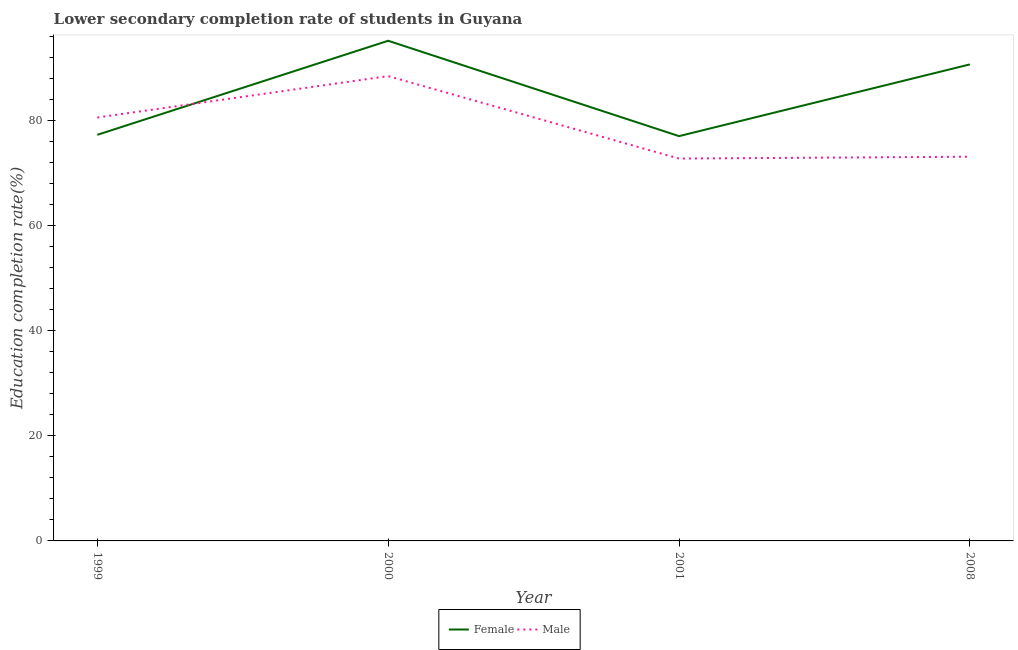How many different coloured lines are there?
Offer a very short reply. 2. Is the number of lines equal to the number of legend labels?
Offer a very short reply. Yes. What is the education completion rate of female students in 2001?
Provide a succinct answer. 77.08. Across all years, what is the maximum education completion rate of female students?
Your answer should be very brief. 95.24. Across all years, what is the minimum education completion rate of male students?
Your answer should be very brief. 72.8. In which year was the education completion rate of male students minimum?
Offer a terse response. 2001. What is the total education completion rate of male students in the graph?
Offer a terse response. 315.09. What is the difference between the education completion rate of female students in 2000 and that in 2001?
Give a very brief answer. 18.16. What is the difference between the education completion rate of female students in 2008 and the education completion rate of male students in 2000?
Provide a short and direct response. 2.23. What is the average education completion rate of male students per year?
Keep it short and to the point. 78.77. In the year 2001, what is the difference between the education completion rate of male students and education completion rate of female students?
Make the answer very short. -4.28. In how many years, is the education completion rate of female students greater than 4 %?
Your answer should be very brief. 4. What is the ratio of the education completion rate of female students in 1999 to that in 2008?
Provide a short and direct response. 0.85. Is the difference between the education completion rate of female students in 1999 and 2000 greater than the difference between the education completion rate of male students in 1999 and 2000?
Offer a terse response. No. What is the difference between the highest and the second highest education completion rate of female students?
Offer a terse response. 4.5. What is the difference between the highest and the lowest education completion rate of male students?
Keep it short and to the point. 15.7. In how many years, is the education completion rate of male students greater than the average education completion rate of male students taken over all years?
Your response must be concise. 2. Is the sum of the education completion rate of female students in 2000 and 2001 greater than the maximum education completion rate of male students across all years?
Your answer should be very brief. Yes. Is the education completion rate of female students strictly greater than the education completion rate of male students over the years?
Your answer should be compact. No. How many lines are there?
Offer a terse response. 2. Are the values on the major ticks of Y-axis written in scientific E-notation?
Make the answer very short. No. Does the graph contain any zero values?
Make the answer very short. No. How many legend labels are there?
Give a very brief answer. 2. What is the title of the graph?
Give a very brief answer. Lower secondary completion rate of students in Guyana. Does "Working only" appear as one of the legend labels in the graph?
Offer a terse response. No. What is the label or title of the X-axis?
Ensure brevity in your answer.  Year. What is the label or title of the Y-axis?
Your response must be concise. Education completion rate(%). What is the Education completion rate(%) of Female in 1999?
Provide a short and direct response. 77.33. What is the Education completion rate(%) of Male in 1999?
Give a very brief answer. 80.62. What is the Education completion rate(%) in Female in 2000?
Your answer should be very brief. 95.24. What is the Education completion rate(%) in Male in 2000?
Keep it short and to the point. 88.5. What is the Education completion rate(%) in Female in 2001?
Provide a short and direct response. 77.08. What is the Education completion rate(%) in Male in 2001?
Your answer should be compact. 72.8. What is the Education completion rate(%) in Female in 2008?
Provide a succinct answer. 90.73. What is the Education completion rate(%) of Male in 2008?
Your answer should be compact. 73.16. Across all years, what is the maximum Education completion rate(%) of Female?
Ensure brevity in your answer.  95.24. Across all years, what is the maximum Education completion rate(%) of Male?
Offer a very short reply. 88.5. Across all years, what is the minimum Education completion rate(%) of Female?
Your answer should be compact. 77.08. Across all years, what is the minimum Education completion rate(%) in Male?
Offer a terse response. 72.8. What is the total Education completion rate(%) of Female in the graph?
Provide a succinct answer. 340.38. What is the total Education completion rate(%) in Male in the graph?
Your answer should be very brief. 315.09. What is the difference between the Education completion rate(%) in Female in 1999 and that in 2000?
Keep it short and to the point. -17.91. What is the difference between the Education completion rate(%) of Male in 1999 and that in 2000?
Your response must be concise. -7.88. What is the difference between the Education completion rate(%) in Female in 1999 and that in 2001?
Your answer should be compact. 0.25. What is the difference between the Education completion rate(%) of Male in 1999 and that in 2001?
Your answer should be compact. 7.82. What is the difference between the Education completion rate(%) in Female in 1999 and that in 2008?
Your answer should be compact. -13.41. What is the difference between the Education completion rate(%) of Male in 1999 and that in 2008?
Provide a short and direct response. 7.47. What is the difference between the Education completion rate(%) of Female in 2000 and that in 2001?
Keep it short and to the point. 18.16. What is the difference between the Education completion rate(%) of Male in 2000 and that in 2001?
Ensure brevity in your answer.  15.7. What is the difference between the Education completion rate(%) of Female in 2000 and that in 2008?
Provide a succinct answer. 4.5. What is the difference between the Education completion rate(%) of Male in 2000 and that in 2008?
Offer a very short reply. 15.34. What is the difference between the Education completion rate(%) of Female in 2001 and that in 2008?
Your answer should be compact. -13.66. What is the difference between the Education completion rate(%) in Male in 2001 and that in 2008?
Ensure brevity in your answer.  -0.36. What is the difference between the Education completion rate(%) in Female in 1999 and the Education completion rate(%) in Male in 2000?
Ensure brevity in your answer.  -11.18. What is the difference between the Education completion rate(%) of Female in 1999 and the Education completion rate(%) of Male in 2001?
Your answer should be compact. 4.52. What is the difference between the Education completion rate(%) in Female in 1999 and the Education completion rate(%) in Male in 2008?
Give a very brief answer. 4.17. What is the difference between the Education completion rate(%) of Female in 2000 and the Education completion rate(%) of Male in 2001?
Make the answer very short. 22.43. What is the difference between the Education completion rate(%) in Female in 2000 and the Education completion rate(%) in Male in 2008?
Make the answer very short. 22.08. What is the difference between the Education completion rate(%) in Female in 2001 and the Education completion rate(%) in Male in 2008?
Give a very brief answer. 3.92. What is the average Education completion rate(%) in Female per year?
Ensure brevity in your answer.  85.09. What is the average Education completion rate(%) in Male per year?
Your response must be concise. 78.77. In the year 1999, what is the difference between the Education completion rate(%) in Female and Education completion rate(%) in Male?
Give a very brief answer. -3.3. In the year 2000, what is the difference between the Education completion rate(%) in Female and Education completion rate(%) in Male?
Provide a short and direct response. 6.73. In the year 2001, what is the difference between the Education completion rate(%) of Female and Education completion rate(%) of Male?
Your response must be concise. 4.28. In the year 2008, what is the difference between the Education completion rate(%) of Female and Education completion rate(%) of Male?
Provide a succinct answer. 17.58. What is the ratio of the Education completion rate(%) in Female in 1999 to that in 2000?
Your answer should be very brief. 0.81. What is the ratio of the Education completion rate(%) of Male in 1999 to that in 2000?
Keep it short and to the point. 0.91. What is the ratio of the Education completion rate(%) in Female in 1999 to that in 2001?
Provide a short and direct response. 1. What is the ratio of the Education completion rate(%) in Male in 1999 to that in 2001?
Provide a succinct answer. 1.11. What is the ratio of the Education completion rate(%) of Female in 1999 to that in 2008?
Offer a terse response. 0.85. What is the ratio of the Education completion rate(%) in Male in 1999 to that in 2008?
Your response must be concise. 1.1. What is the ratio of the Education completion rate(%) of Female in 2000 to that in 2001?
Your response must be concise. 1.24. What is the ratio of the Education completion rate(%) of Male in 2000 to that in 2001?
Make the answer very short. 1.22. What is the ratio of the Education completion rate(%) in Female in 2000 to that in 2008?
Provide a succinct answer. 1.05. What is the ratio of the Education completion rate(%) in Male in 2000 to that in 2008?
Your answer should be compact. 1.21. What is the ratio of the Education completion rate(%) of Female in 2001 to that in 2008?
Your answer should be compact. 0.85. What is the ratio of the Education completion rate(%) in Male in 2001 to that in 2008?
Keep it short and to the point. 1. What is the difference between the highest and the second highest Education completion rate(%) of Female?
Make the answer very short. 4.5. What is the difference between the highest and the second highest Education completion rate(%) of Male?
Provide a short and direct response. 7.88. What is the difference between the highest and the lowest Education completion rate(%) in Female?
Make the answer very short. 18.16. What is the difference between the highest and the lowest Education completion rate(%) of Male?
Ensure brevity in your answer.  15.7. 